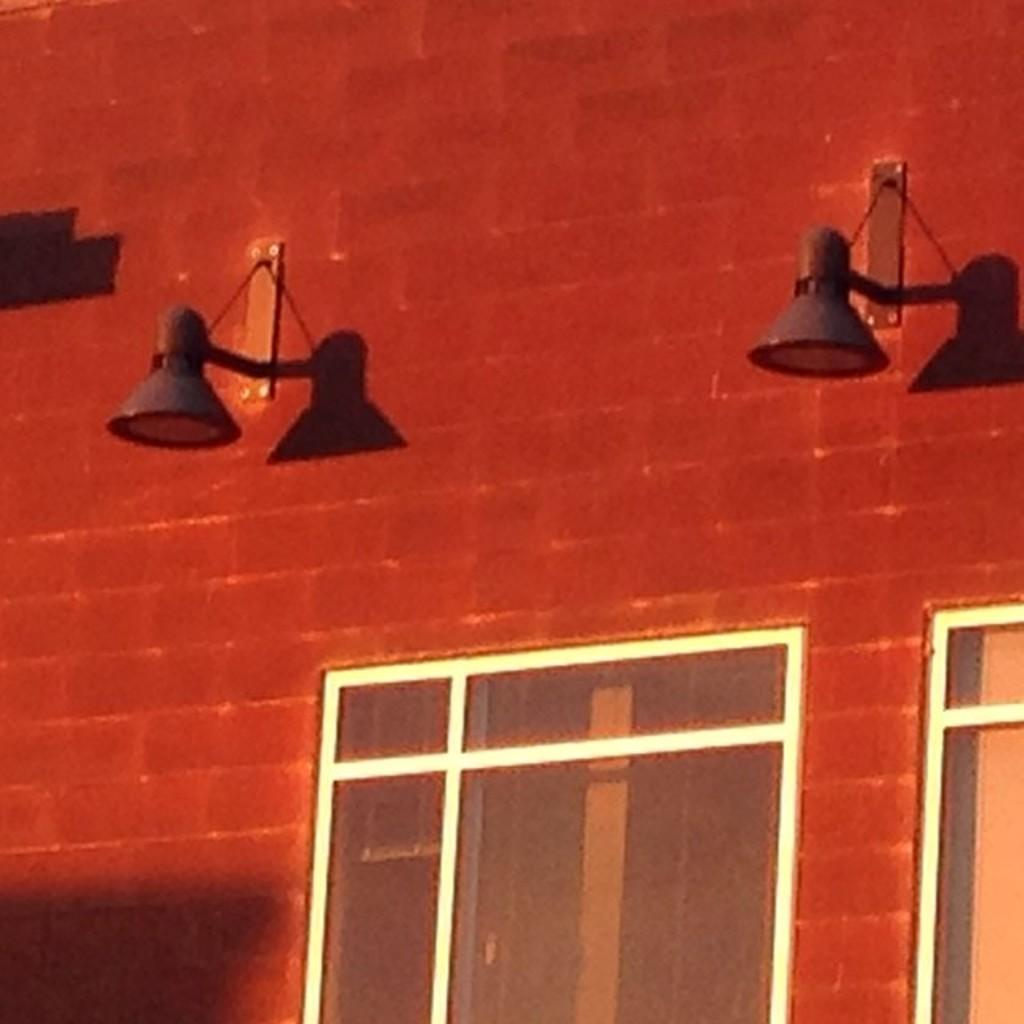What is the main feature of the image? There is a wall in the image. What color is the wall? The wall is red in color. Are there any openings in the wall? Yes, there are windows on the wall. What can be seen on the windows? Lights are visible on the windows. Can you see a plough in the field behind the wall in the image? There is no field or plough present in the image; it only features a red wall with windows and lights. 